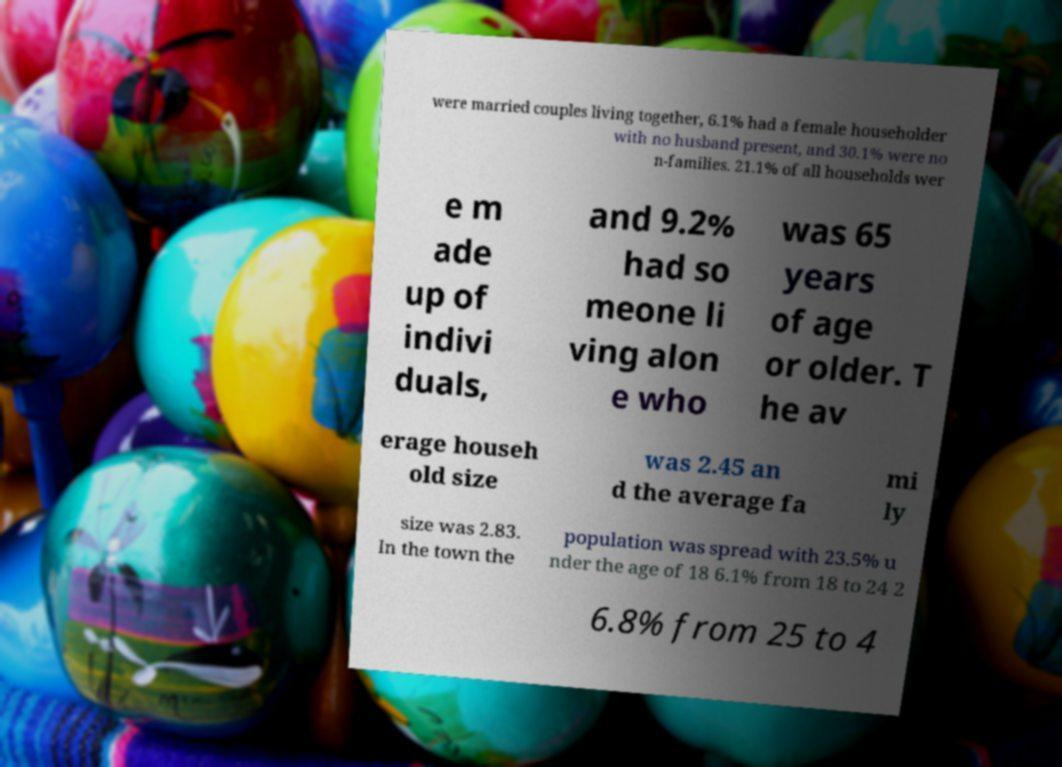Please identify and transcribe the text found in this image. were married couples living together, 6.1% had a female householder with no husband present, and 30.1% were no n-families. 21.1% of all households wer e m ade up of indivi duals, and 9.2% had so meone li ving alon e who was 65 years of age or older. T he av erage househ old size was 2.45 an d the average fa mi ly size was 2.83. In the town the population was spread with 23.5% u nder the age of 18 6.1% from 18 to 24 2 6.8% from 25 to 4 